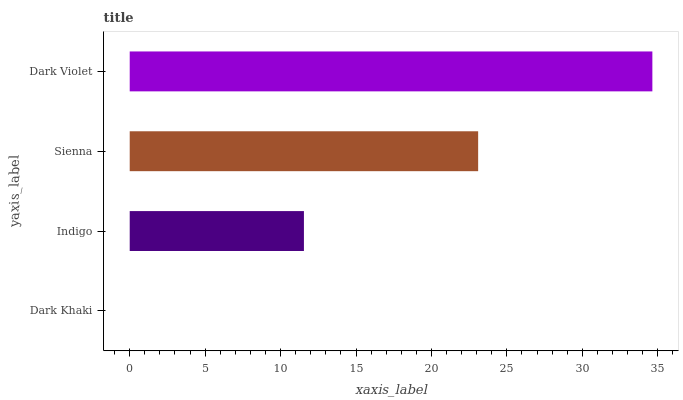Is Dark Khaki the minimum?
Answer yes or no. Yes. Is Dark Violet the maximum?
Answer yes or no. Yes. Is Indigo the minimum?
Answer yes or no. No. Is Indigo the maximum?
Answer yes or no. No. Is Indigo greater than Dark Khaki?
Answer yes or no. Yes. Is Dark Khaki less than Indigo?
Answer yes or no. Yes. Is Dark Khaki greater than Indigo?
Answer yes or no. No. Is Indigo less than Dark Khaki?
Answer yes or no. No. Is Sienna the high median?
Answer yes or no. Yes. Is Indigo the low median?
Answer yes or no. Yes. Is Dark Khaki the high median?
Answer yes or no. No. Is Dark Violet the low median?
Answer yes or no. No. 